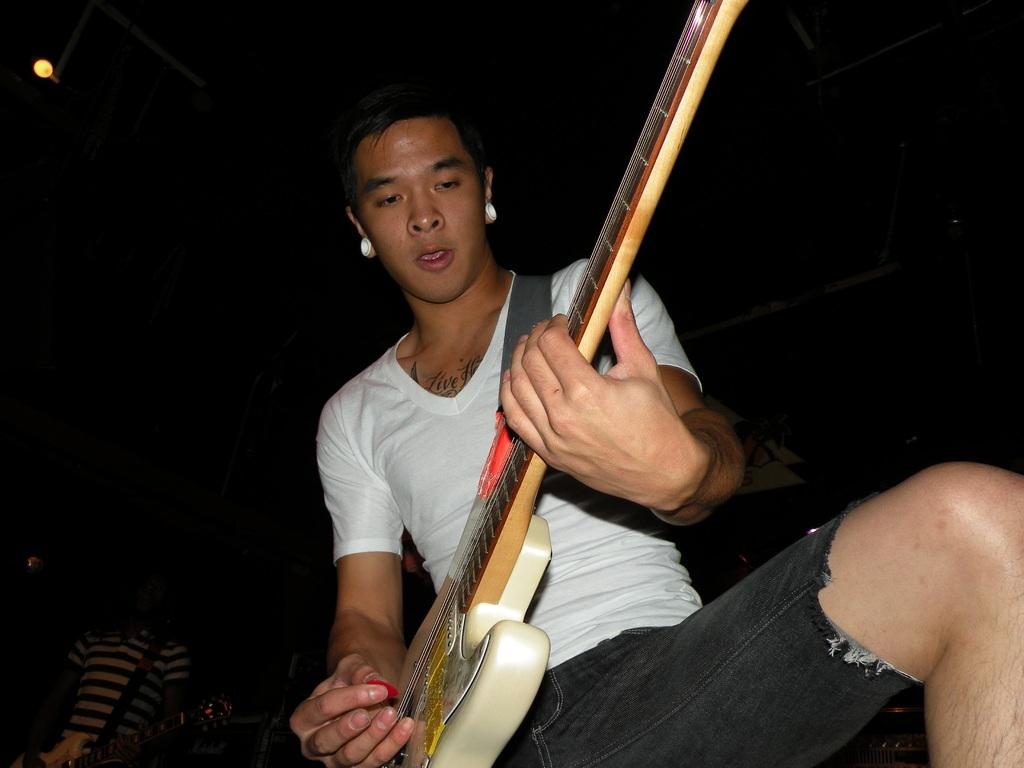What is the overall color scheme of the image? The background of the image is dark. Is there any source of light in the image? Yes, there is a light visible in the image. Who is the person in the image? There is a man in the image. What is the man wearing? The man is wearing a white shirt. What is the man doing in the image? The man is playing a guitar. What type of tax is being discussed in the image? There is no discussion of tax in the image; it features a man playing a guitar. What color is the dress worn by the man in the image? The man is not wearing a dress in the image; he is wearing a white shirt. 